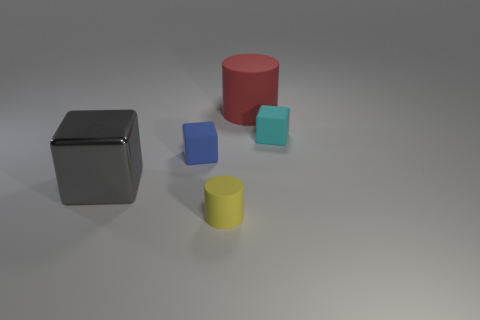Are there fewer cyan rubber things to the right of the red cylinder than big cubes?
Your answer should be compact. No. Is there a blue block that has the same size as the gray cube?
Provide a short and direct response. No. There is a large rubber cylinder; is its color the same as the small rubber cube that is on the left side of the cyan matte block?
Make the answer very short. No. There is a cube that is on the right side of the red rubber cylinder; what number of things are left of it?
Ensure brevity in your answer.  4. The object on the right side of the rubber cylinder behind the small yellow rubber cylinder is what color?
Make the answer very short. Cyan. What is the object that is both right of the blue thing and on the left side of the big matte thing made of?
Provide a succinct answer. Rubber. Are there any small green metal objects that have the same shape as the small blue matte object?
Provide a succinct answer. No. There is a large object to the left of the yellow cylinder; does it have the same shape as the large red object?
Keep it short and to the point. No. How many things are to the left of the cyan thing and right of the large gray shiny object?
Keep it short and to the point. 3. What is the shape of the big thing that is to the right of the gray block?
Offer a very short reply. Cylinder. 